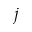Convert formula to latex. <formula><loc_0><loc_0><loc_500><loc_500>j</formula> 